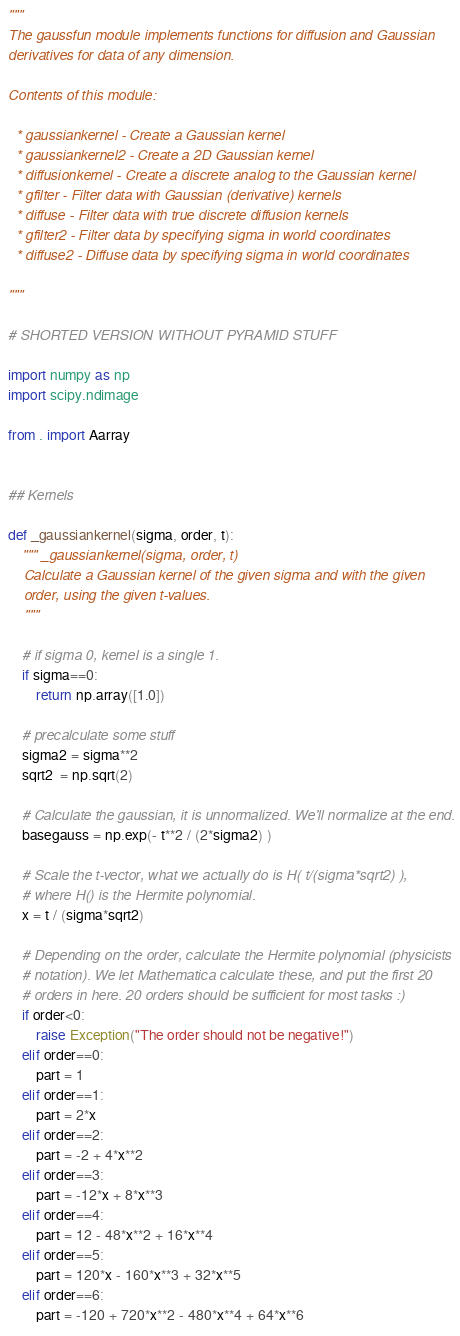Convert code to text. <code><loc_0><loc_0><loc_500><loc_500><_Python_>"""
The gaussfun module implements functions for diffusion and Gaussian
derivatives for data of any dimension.

Contents of this module:

  * gaussiankernel - Create a Gaussian kernel
  * gaussiankernel2 - Create a 2D Gaussian kernel
  * diffusionkernel - Create a discrete analog to the Gaussian kernel
  * gfilter - Filter data with Gaussian (derivative) kernels
  * diffuse - Filter data with true discrete diffusion kernels
  * gfilter2 - Filter data by specifying sigma in world coordinates
  * diffuse2 - Diffuse data by specifying sigma in world coordinates

"""

# SHORTED VERSION WITHOUT PYRAMID STUFF

import numpy as np
import scipy.ndimage

from . import Aarray


## Kernels

def _gaussiankernel(sigma, order, t):
    """ _gaussiankernel(sigma, order, t)
    Calculate a Gaussian kernel of the given sigma and with the given
    order, using the given t-values. 
    """
    
    # if sigma 0, kernel is a single 1.
    if sigma==0:
        return np.array([1.0])
    
    # precalculate some stuff
    sigma2 = sigma**2
    sqrt2  = np.sqrt(2)
    
    # Calculate the gaussian, it is unnormalized. We'll normalize at the end.
    basegauss = np.exp(- t**2 / (2*sigma2) )
    
    # Scale the t-vector, what we actually do is H( t/(sigma*sqrt2) ), 
    # where H() is the Hermite polynomial. 
    x = t / (sigma*sqrt2)
    
    # Depending on the order, calculate the Hermite polynomial (physicists 
    # notation). We let Mathematica calculate these, and put the first 20 
    # orders in here. 20 orders should be sufficient for most tasks :)
    if order<0: 
        raise Exception("The order should not be negative!")    
    elif order==0:
        part = 1
    elif order==1:
        part = 2*x
    elif order==2:
        part = -2 + 4*x**2
    elif order==3:
        part = -12*x + 8*x**3
    elif order==4:
        part = 12 - 48*x**2 + 16*x**4
    elif order==5:
        part = 120*x - 160*x**3 + 32*x**5
    elif order==6:
        part = -120 + 720*x**2 - 480*x**4 + 64*x**6</code> 